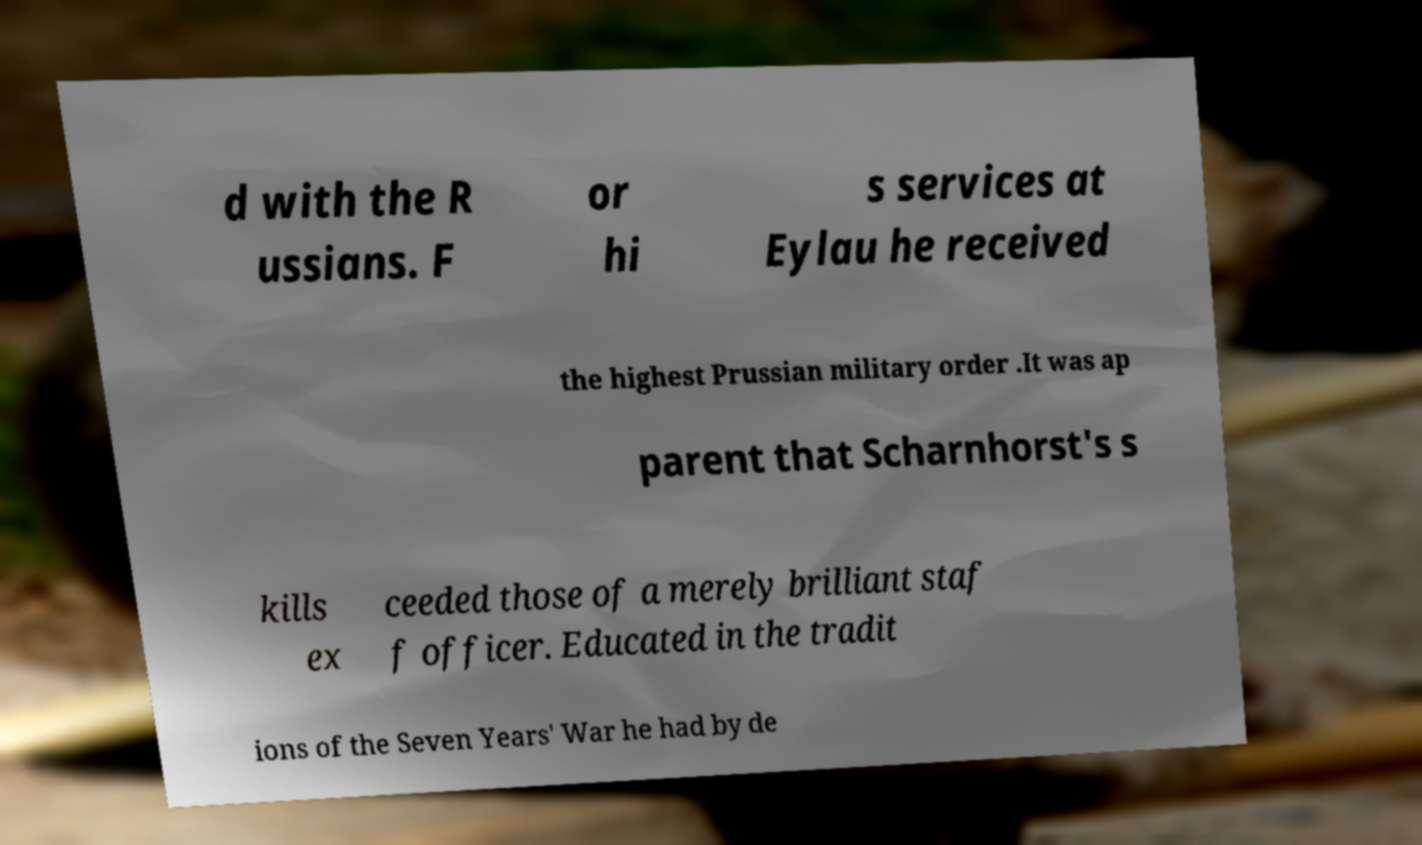Could you assist in decoding the text presented in this image and type it out clearly? d with the R ussians. F or hi s services at Eylau he received the highest Prussian military order .It was ap parent that Scharnhorst's s kills ex ceeded those of a merely brilliant staf f officer. Educated in the tradit ions of the Seven Years' War he had by de 